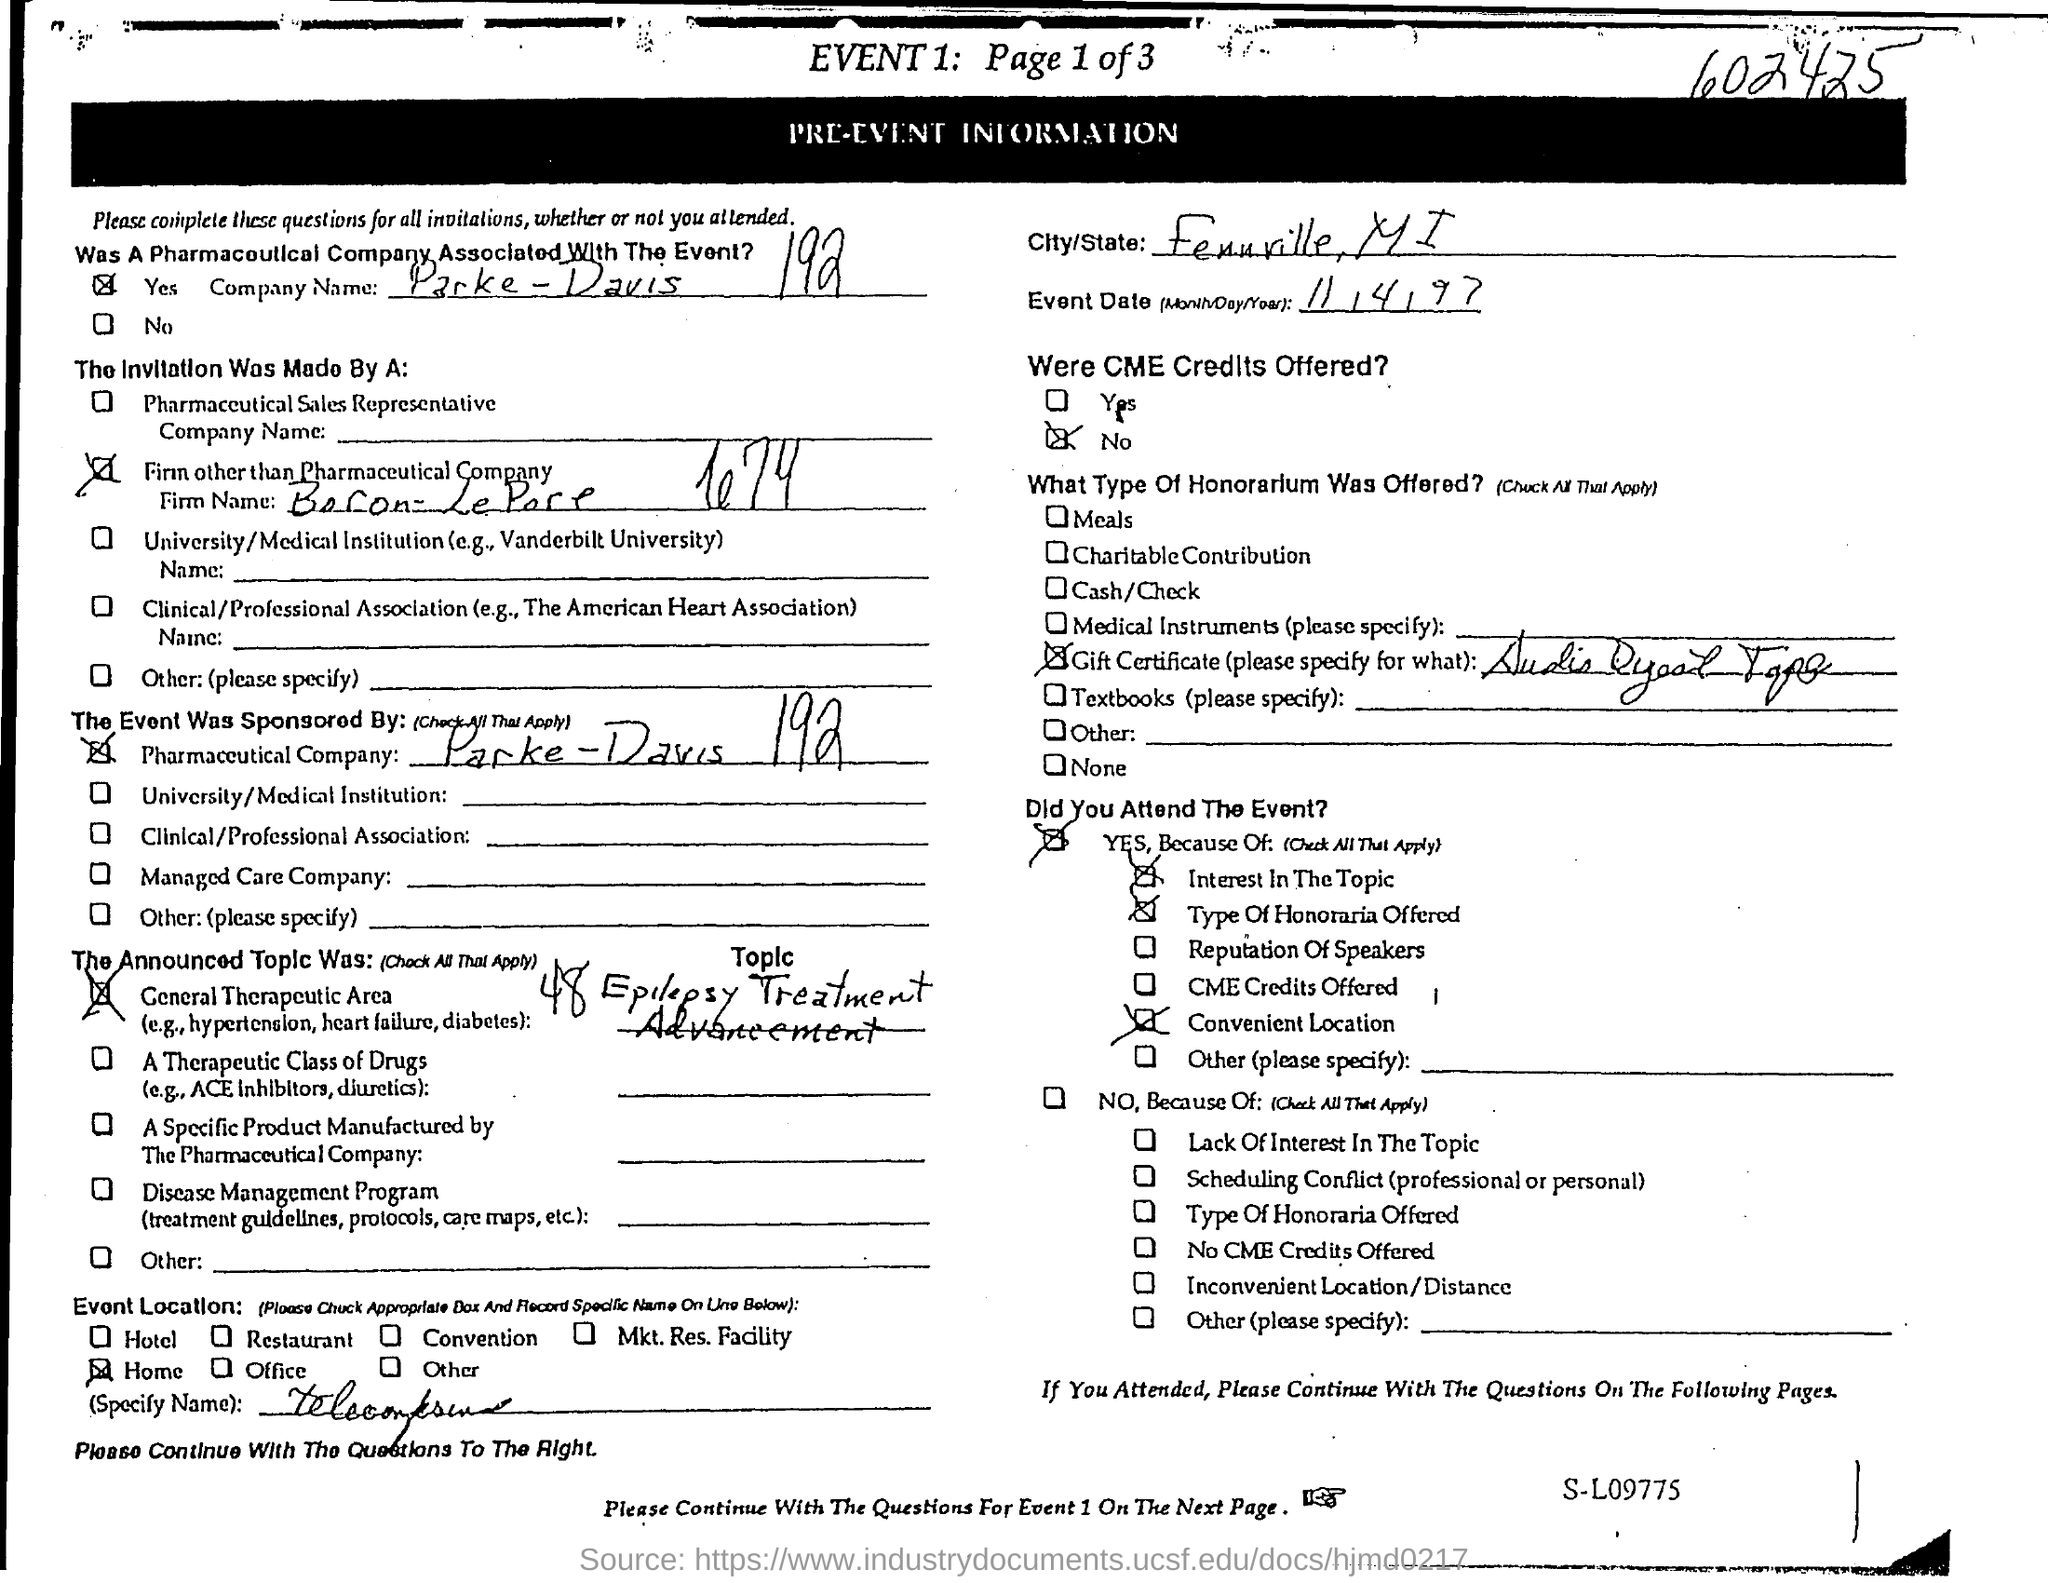Specify some key components in this picture. The number mentioned at the top right corner is 602425. What is the event date? 11/4/97. Parke-Davis, a pharmaceutical company, was founded in 192... 